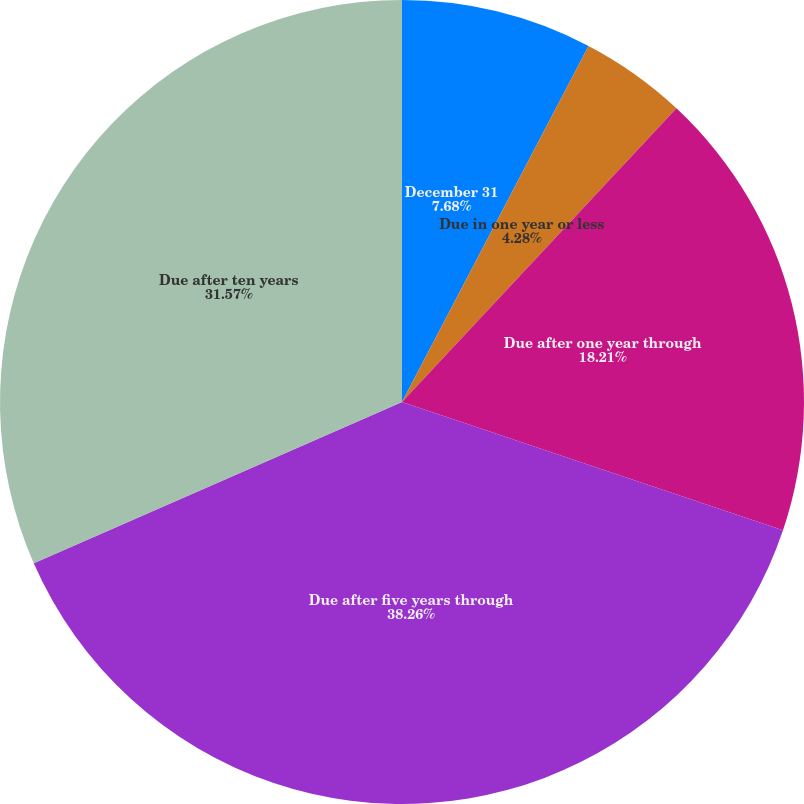Convert chart. <chart><loc_0><loc_0><loc_500><loc_500><pie_chart><fcel>December 31<fcel>Due in one year or less<fcel>Due after one year through<fcel>Due after five years through<fcel>Due after ten years<nl><fcel>7.68%<fcel>4.28%<fcel>18.21%<fcel>38.26%<fcel>31.57%<nl></chart> 